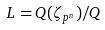<formula> <loc_0><loc_0><loc_500><loc_500>L = Q ( \zeta _ { p ^ { n } } ) / Q</formula> 